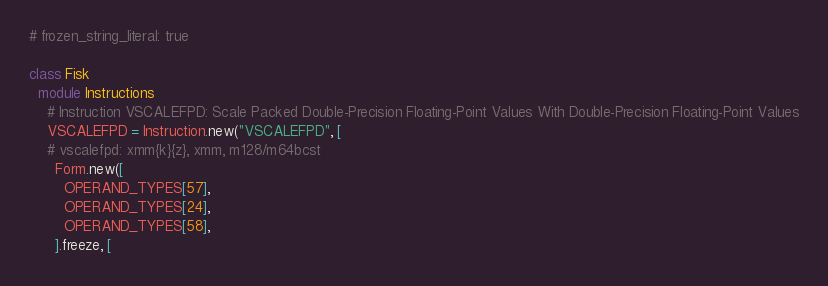Convert code to text. <code><loc_0><loc_0><loc_500><loc_500><_Ruby_># frozen_string_literal: true

class Fisk
  module Instructions
    # Instruction VSCALEFPD: Scale Packed Double-Precision Floating-Point Values With Double-Precision Floating-Point Values
    VSCALEFPD = Instruction.new("VSCALEFPD", [
    # vscalefpd: xmm{k}{z}, xmm, m128/m64bcst
      Form.new([
        OPERAND_TYPES[57],
        OPERAND_TYPES[24],
        OPERAND_TYPES[58],
      ].freeze, [</code> 